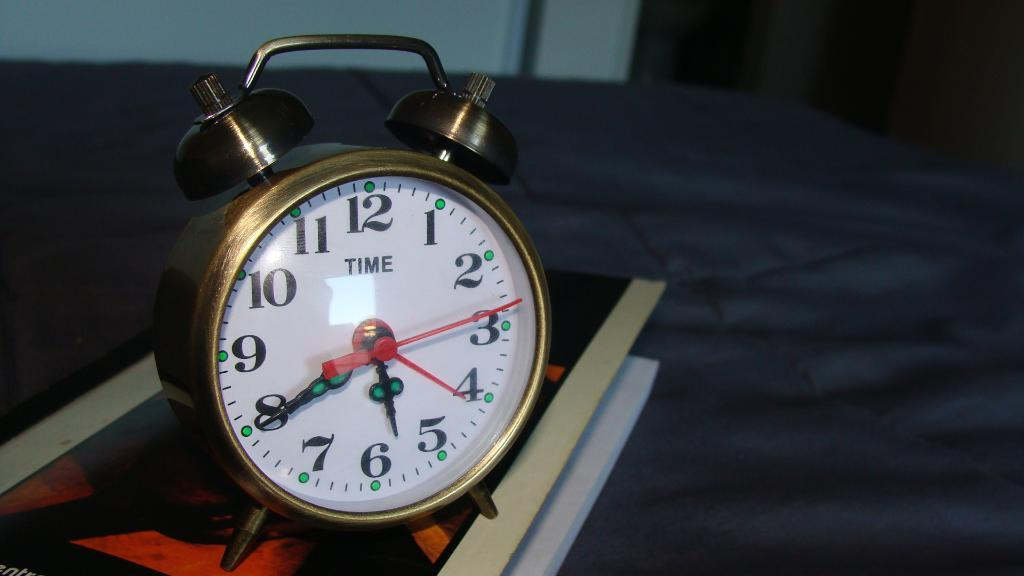<image>
Describe the image concisely. A vintage clock that has the word time on it 